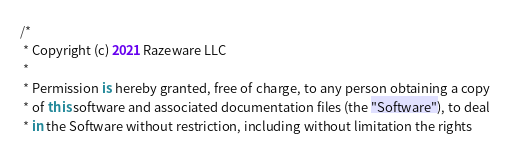<code> <loc_0><loc_0><loc_500><loc_500><_Kotlin_>/*
 * Copyright (c) 2021 Razeware LLC
 * 
 * Permission is hereby granted, free of charge, to any person obtaining a copy
 * of this software and associated documentation files (the "Software"), to deal
 * in the Software without restriction, including without limitation the rights</code> 